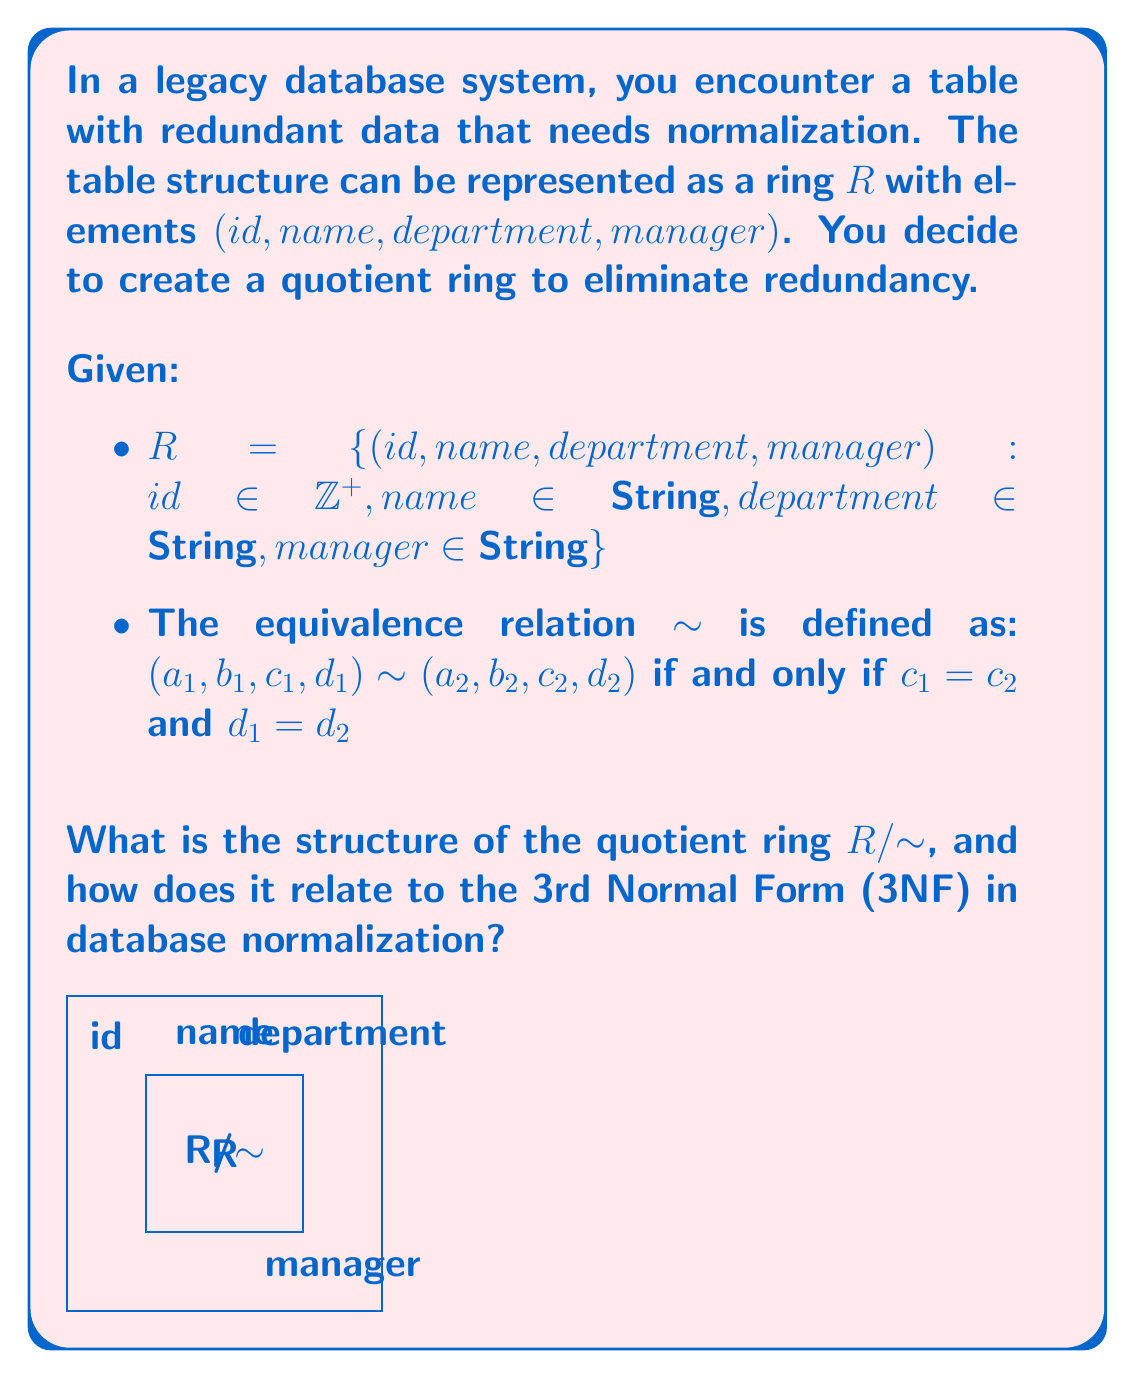What is the answer to this math problem? Let's approach this step-by-step:

1) First, let's understand what the quotient ring $R/{\sim}$ represents:
   - It's the set of all equivalence classes under the relation $\sim$.
   - Each equivalence class contains all elements of $R$ with the same department and manager.

2) Structure of $R/{\sim}$:
   - Elements of $R/{\sim}$ are of the form $[(id, name, department, manager)]$, where $[.]$ denotes an equivalence class.
   - The $id$ and $name$ can vary within an equivalence class, but $department$ and $manager$ are fixed.

3) Relation to 3NF:
   - 3NF requires that non-prime attributes (attributes not part of any candidate key) must be:
     a) Fully functionally dependent on the primary key
     b) Independent of other non-prime attributes

4) In our case:
   - The quotient ring $R/{\sim}$ effectively separates the $department$ and $manager$ attributes.
   - This separation aligns with 3NF by removing the transitive dependency between $id$ and $manager$ through $department$.

5) The structure of $R/{\sim}$ can be seen as two related tables:
   - Table 1: $(id, name, department)$
   - Table 2: $(department, manager)$

6) This structure eliminates redundancy because:
   - Each department-manager pair is stored only once in Table 2.
   - Table 1 references the department, which can then be used to look up the manager in Table 2.

7) In ring theory terms:
   - $R/{\sim}$ is isomorphic to the direct product of two rings:
     $R/{\sim} \cong R_1 \times R_2$
   where $R_1$ represents the $(id, name)$ pairs and $R_2$ represents the $(department, manager)$ pairs.
Answer: $R/{\sim} \cong R_1 \times R_2$, where $R_1$ represents $(id, name)$ and $R_2$ represents $(department, manager)$, aligning with 3NF by separating transitive dependencies. 